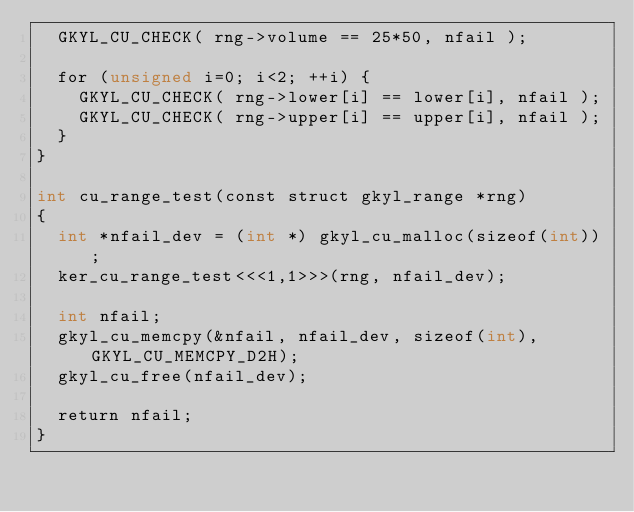Convert code to text. <code><loc_0><loc_0><loc_500><loc_500><_Cuda_>  GKYL_CU_CHECK( rng->volume == 25*50, nfail );

  for (unsigned i=0; i<2; ++i) {
    GKYL_CU_CHECK( rng->lower[i] == lower[i], nfail );
    GKYL_CU_CHECK( rng->upper[i] == upper[i], nfail );
  }  
}

int cu_range_test(const struct gkyl_range *rng)
{
  int *nfail_dev = (int *) gkyl_cu_malloc(sizeof(int));  
  ker_cu_range_test<<<1,1>>>(rng, nfail_dev);

  int nfail;
  gkyl_cu_memcpy(&nfail, nfail_dev, sizeof(int), GKYL_CU_MEMCPY_D2H);
  gkyl_cu_free(nfail_dev);

  return nfail;  
}


</code> 